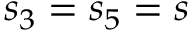Convert formula to latex. <formula><loc_0><loc_0><loc_500><loc_500>s _ { 3 } = s _ { 5 } = s</formula> 